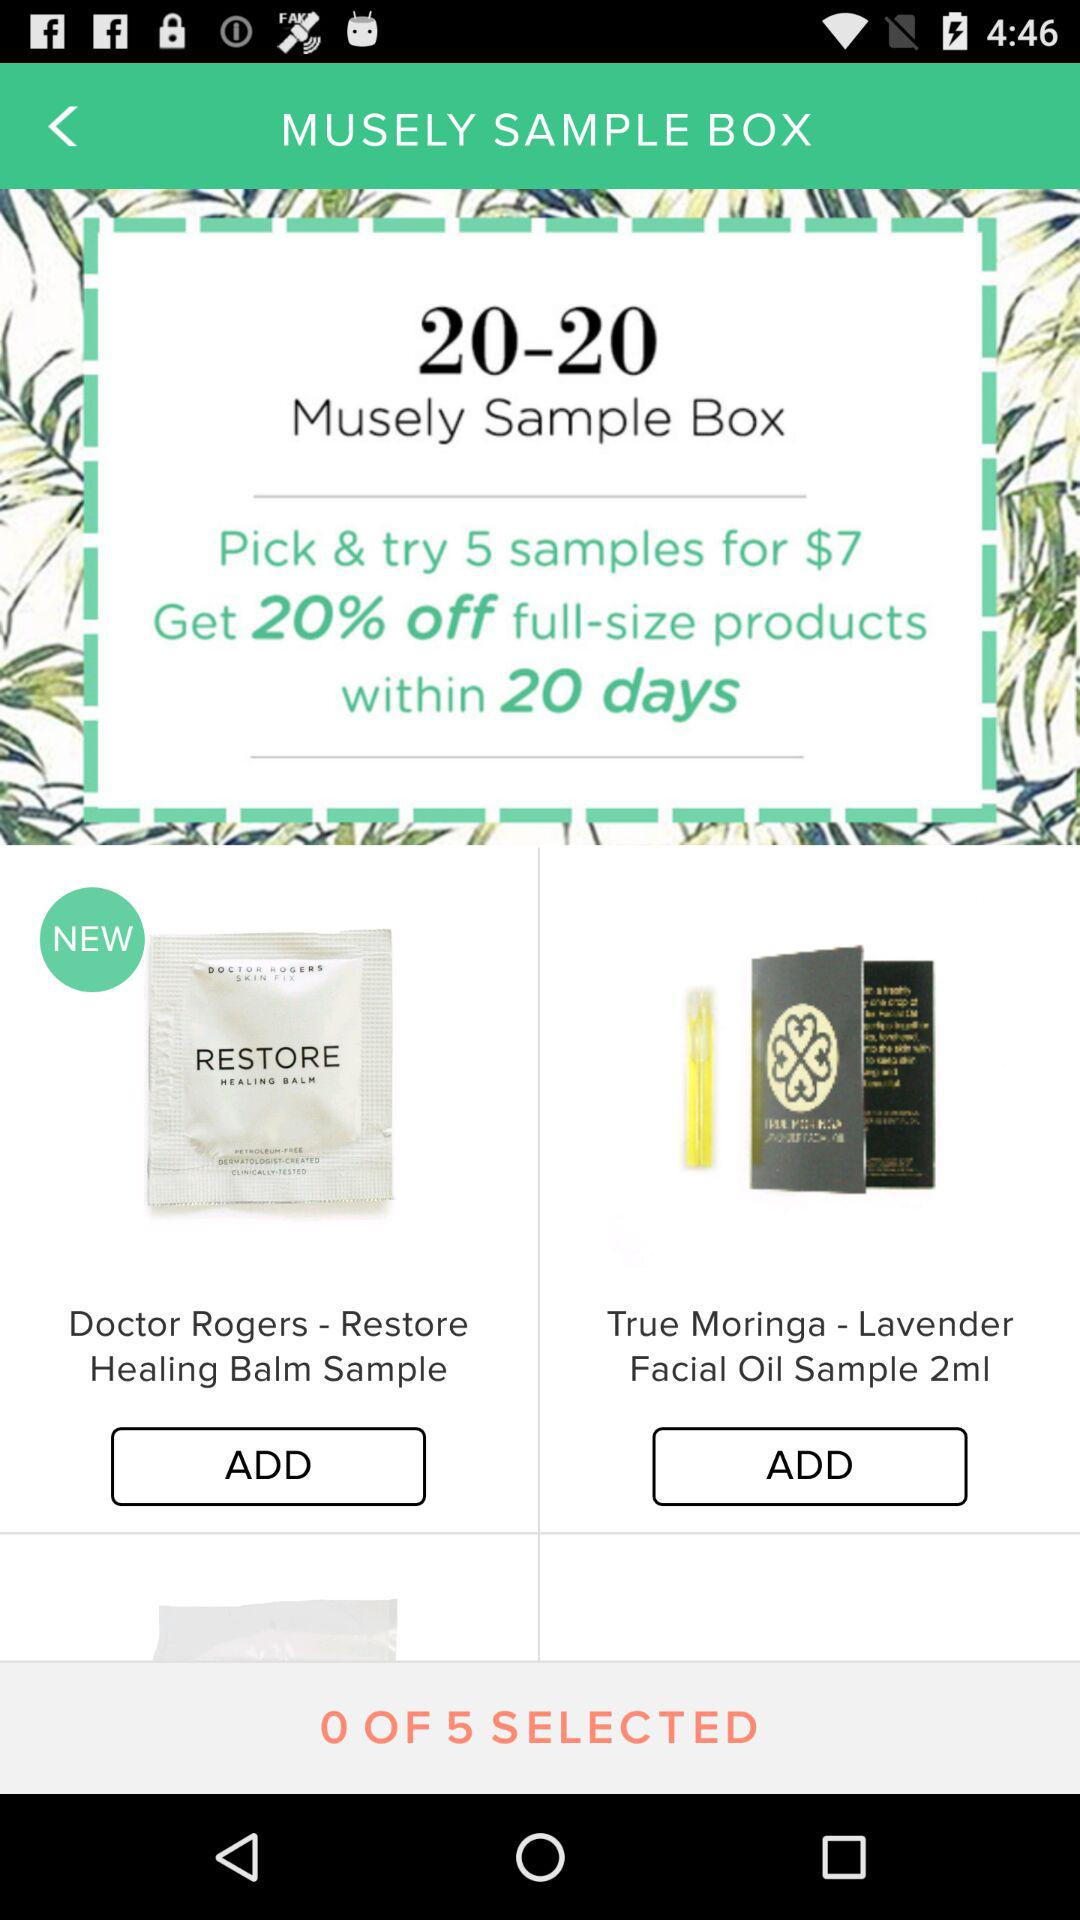How much do 5 samples cost? Five samples cost $7. 